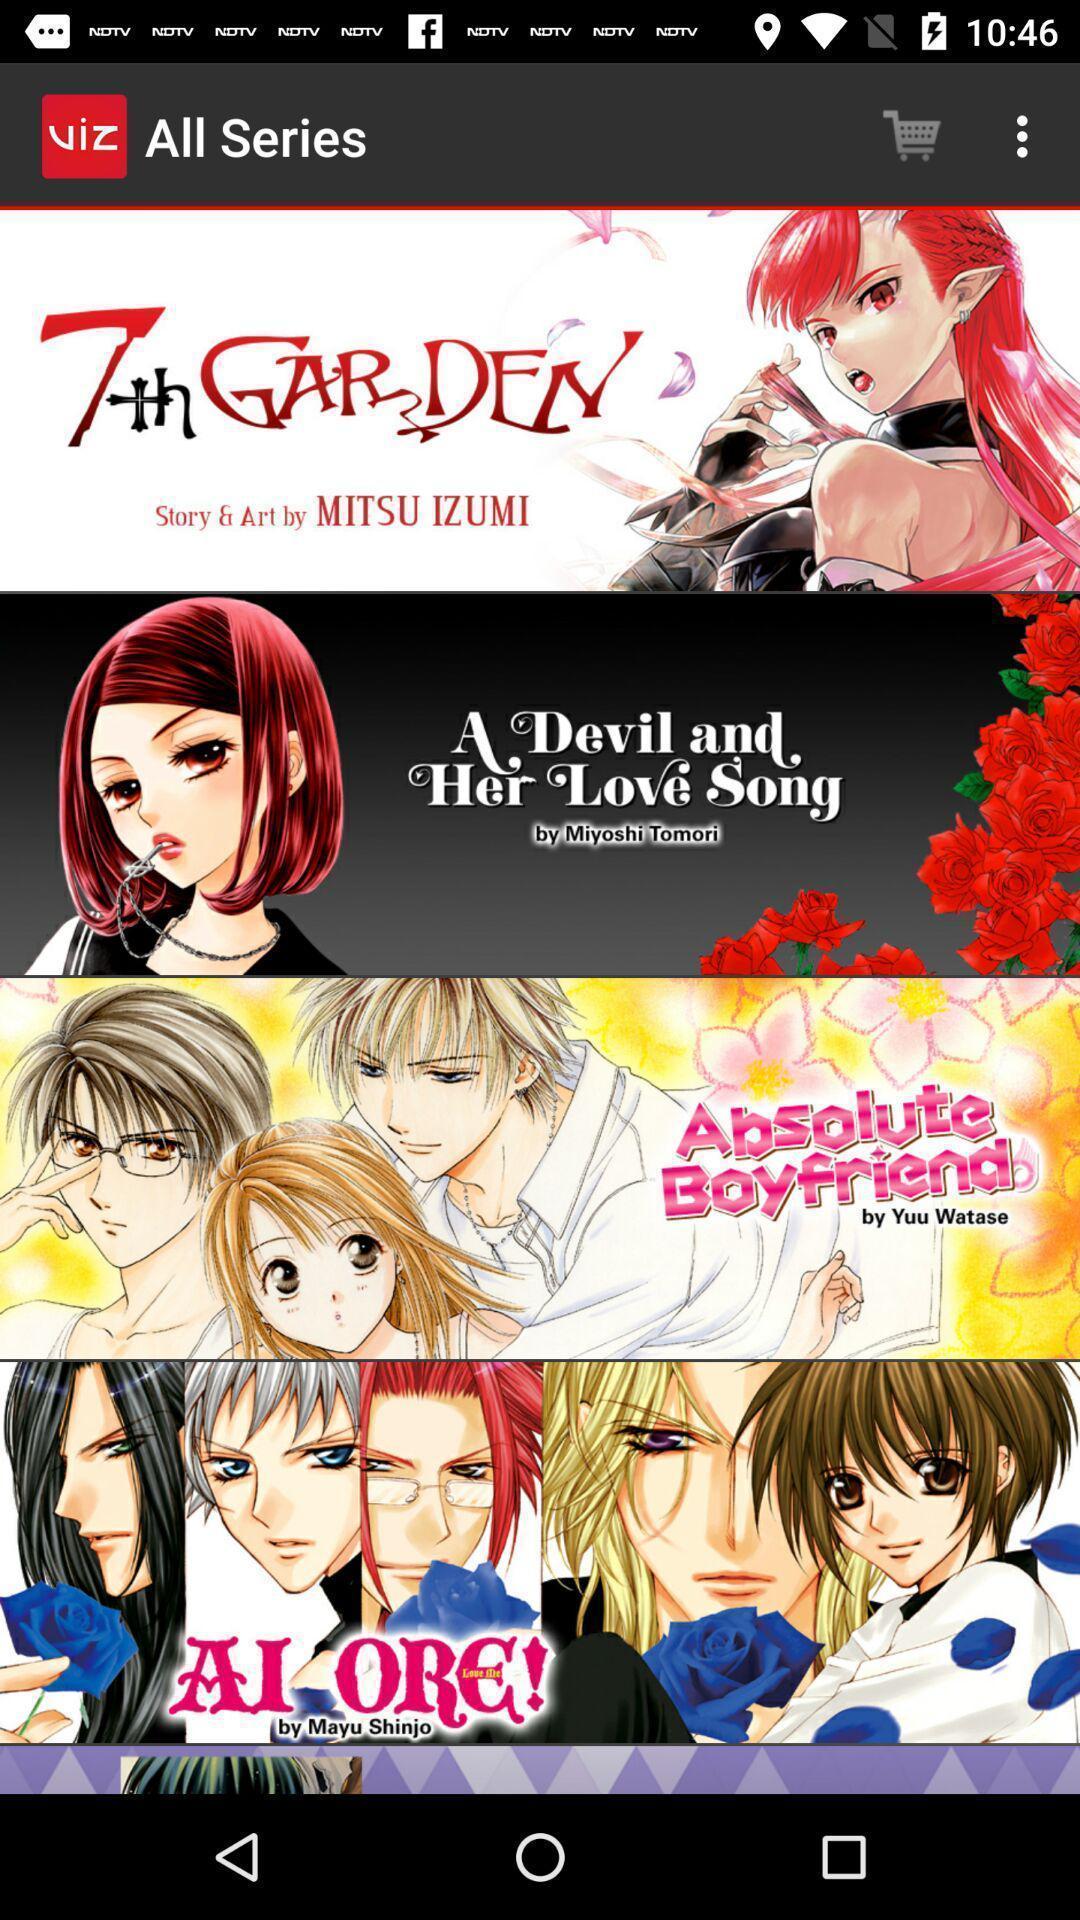Describe the visual elements of this screenshot. Various series of the animated stories in application. 